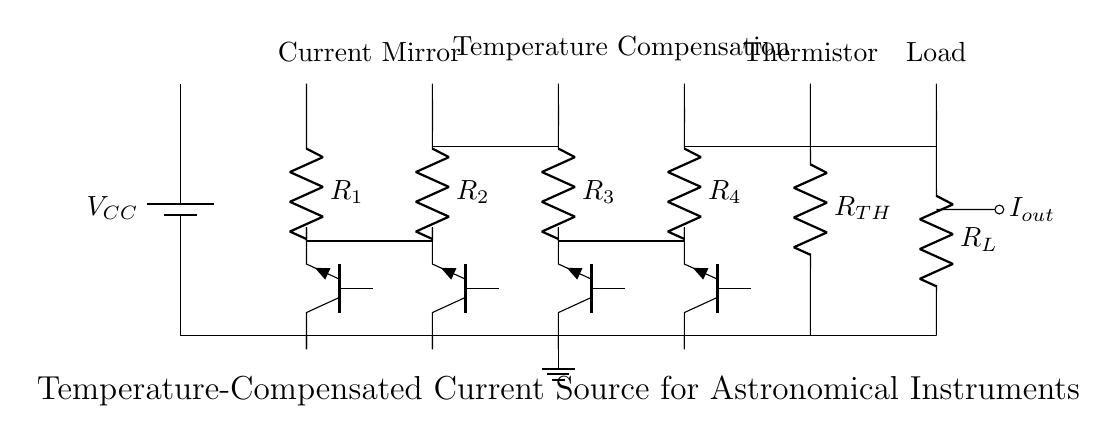What is the type of the load resistor? The load resistor is represented as a resistor symbol in the circuit diagram, which indicates it is a passive component used to consume power.
Answer: Resistor How many transistors are used in the current source circuit? The circuit shows four distinct transistor symbols (Tnpn) labeled as Q1, Q2, Q3, and Q4, which confirms their presence as crucial active components in the circuit.
Answer: Four What is the function of the thermistor in this circuit? The thermistor is employed to sense the temperature changes and provide feedback, helping to stabilize the current output by compensating for temperature variations.
Answer: Temperature compensation What is the overall purpose of the circuit diagram? The multiple components and their arrangement suggest that this circuit aims to maintain a stable current output for sensitive astronomical instruments by using temperature compensation techniques.
Answer: Stabilizing current Which component directly provides temperature feedback? The thermistor, as it reacts to temperature variations and influences the circuit's performance by adjusting the current accordingly.
Answer: Thermistor What does the label R_TH indicate in this circuit? The label indicates the resistance value of the thermistor, defining its role in measuring temperature and affecting current stability.
Answer: Thermistor resistance What are the two groups of components in the circuit topology? The circuit separates into two functions: the current mirror and the temperature compensation section, which work in conjunction to stabilize the output current.
Answer: Current mirror and temperature compensation 